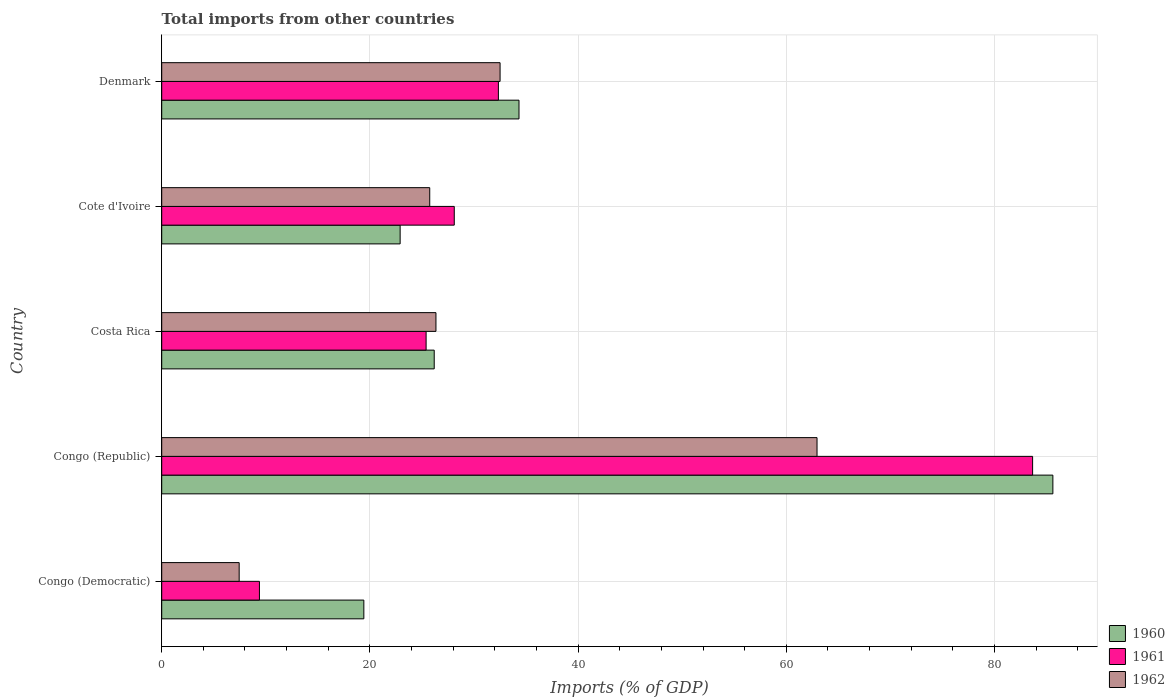How many different coloured bars are there?
Your response must be concise. 3. Are the number of bars per tick equal to the number of legend labels?
Ensure brevity in your answer.  Yes. Are the number of bars on each tick of the Y-axis equal?
Offer a terse response. Yes. How many bars are there on the 1st tick from the top?
Your answer should be very brief. 3. What is the total imports in 1961 in Costa Rica?
Your answer should be very brief. 25.4. Across all countries, what is the maximum total imports in 1961?
Provide a succinct answer. 83.66. Across all countries, what is the minimum total imports in 1961?
Your answer should be compact. 9.39. In which country was the total imports in 1960 maximum?
Give a very brief answer. Congo (Republic). In which country was the total imports in 1961 minimum?
Your answer should be compact. Congo (Democratic). What is the total total imports in 1962 in the graph?
Ensure brevity in your answer.  154.99. What is the difference between the total imports in 1960 in Congo (Republic) and that in Cote d'Ivoire?
Offer a terse response. 62.7. What is the difference between the total imports in 1960 in Denmark and the total imports in 1962 in Costa Rica?
Keep it short and to the point. 7.98. What is the average total imports in 1962 per country?
Give a very brief answer. 31. What is the difference between the total imports in 1960 and total imports in 1961 in Denmark?
Offer a very short reply. 1.98. In how many countries, is the total imports in 1962 greater than 68 %?
Your response must be concise. 0. What is the ratio of the total imports in 1961 in Costa Rica to that in Cote d'Ivoire?
Offer a very short reply. 0.9. Is the total imports in 1960 in Congo (Democratic) less than that in Congo (Republic)?
Keep it short and to the point. Yes. What is the difference between the highest and the second highest total imports in 1962?
Make the answer very short. 30.45. What is the difference between the highest and the lowest total imports in 1961?
Your answer should be very brief. 74.27. Is the sum of the total imports in 1961 in Congo (Democratic) and Denmark greater than the maximum total imports in 1962 across all countries?
Your answer should be compact. No. Is it the case that in every country, the sum of the total imports in 1960 and total imports in 1961 is greater than the total imports in 1962?
Keep it short and to the point. Yes. Are all the bars in the graph horizontal?
Offer a terse response. Yes. How many countries are there in the graph?
Make the answer very short. 5. What is the difference between two consecutive major ticks on the X-axis?
Ensure brevity in your answer.  20. Are the values on the major ticks of X-axis written in scientific E-notation?
Your answer should be compact. No. How are the legend labels stacked?
Keep it short and to the point. Vertical. What is the title of the graph?
Your response must be concise. Total imports from other countries. What is the label or title of the X-axis?
Give a very brief answer. Imports (% of GDP). What is the Imports (% of GDP) of 1960 in Congo (Democratic)?
Provide a short and direct response. 19.42. What is the Imports (% of GDP) of 1961 in Congo (Democratic)?
Keep it short and to the point. 9.39. What is the Imports (% of GDP) in 1962 in Congo (Democratic)?
Your answer should be compact. 7.44. What is the Imports (% of GDP) of 1960 in Congo (Republic)?
Ensure brevity in your answer.  85.61. What is the Imports (% of GDP) in 1961 in Congo (Republic)?
Your answer should be very brief. 83.66. What is the Imports (% of GDP) in 1962 in Congo (Republic)?
Give a very brief answer. 62.95. What is the Imports (% of GDP) of 1960 in Costa Rica?
Give a very brief answer. 26.18. What is the Imports (% of GDP) of 1961 in Costa Rica?
Provide a succinct answer. 25.4. What is the Imports (% of GDP) in 1962 in Costa Rica?
Your answer should be compact. 26.34. What is the Imports (% of GDP) of 1960 in Cote d'Ivoire?
Ensure brevity in your answer.  22.9. What is the Imports (% of GDP) of 1961 in Cote d'Ivoire?
Offer a terse response. 28.1. What is the Imports (% of GDP) in 1962 in Cote d'Ivoire?
Keep it short and to the point. 25.75. What is the Imports (% of GDP) of 1960 in Denmark?
Ensure brevity in your answer.  34.32. What is the Imports (% of GDP) in 1961 in Denmark?
Offer a terse response. 32.34. What is the Imports (% of GDP) in 1962 in Denmark?
Ensure brevity in your answer.  32.5. Across all countries, what is the maximum Imports (% of GDP) of 1960?
Give a very brief answer. 85.61. Across all countries, what is the maximum Imports (% of GDP) in 1961?
Give a very brief answer. 83.66. Across all countries, what is the maximum Imports (% of GDP) of 1962?
Your answer should be compact. 62.95. Across all countries, what is the minimum Imports (% of GDP) of 1960?
Your answer should be very brief. 19.42. Across all countries, what is the minimum Imports (% of GDP) in 1961?
Provide a short and direct response. 9.39. Across all countries, what is the minimum Imports (% of GDP) of 1962?
Offer a terse response. 7.44. What is the total Imports (% of GDP) of 1960 in the graph?
Ensure brevity in your answer.  188.43. What is the total Imports (% of GDP) of 1961 in the graph?
Provide a short and direct response. 178.89. What is the total Imports (% of GDP) of 1962 in the graph?
Your answer should be compact. 154.99. What is the difference between the Imports (% of GDP) of 1960 in Congo (Democratic) and that in Congo (Republic)?
Keep it short and to the point. -66.19. What is the difference between the Imports (% of GDP) of 1961 in Congo (Democratic) and that in Congo (Republic)?
Give a very brief answer. -74.27. What is the difference between the Imports (% of GDP) in 1962 in Congo (Democratic) and that in Congo (Republic)?
Offer a very short reply. -55.51. What is the difference between the Imports (% of GDP) of 1960 in Congo (Democratic) and that in Costa Rica?
Offer a very short reply. -6.76. What is the difference between the Imports (% of GDP) in 1961 in Congo (Democratic) and that in Costa Rica?
Your answer should be compact. -16.01. What is the difference between the Imports (% of GDP) of 1962 in Congo (Democratic) and that in Costa Rica?
Provide a succinct answer. -18.9. What is the difference between the Imports (% of GDP) in 1960 in Congo (Democratic) and that in Cote d'Ivoire?
Give a very brief answer. -3.49. What is the difference between the Imports (% of GDP) of 1961 in Congo (Democratic) and that in Cote d'Ivoire?
Provide a succinct answer. -18.72. What is the difference between the Imports (% of GDP) in 1962 in Congo (Democratic) and that in Cote d'Ivoire?
Make the answer very short. -18.31. What is the difference between the Imports (% of GDP) in 1960 in Congo (Democratic) and that in Denmark?
Your response must be concise. -14.91. What is the difference between the Imports (% of GDP) of 1961 in Congo (Democratic) and that in Denmark?
Your answer should be very brief. -22.96. What is the difference between the Imports (% of GDP) of 1962 in Congo (Democratic) and that in Denmark?
Offer a very short reply. -25.06. What is the difference between the Imports (% of GDP) of 1960 in Congo (Republic) and that in Costa Rica?
Provide a succinct answer. 59.43. What is the difference between the Imports (% of GDP) in 1961 in Congo (Republic) and that in Costa Rica?
Offer a terse response. 58.26. What is the difference between the Imports (% of GDP) of 1962 in Congo (Republic) and that in Costa Rica?
Keep it short and to the point. 36.61. What is the difference between the Imports (% of GDP) of 1960 in Congo (Republic) and that in Cote d'Ivoire?
Give a very brief answer. 62.7. What is the difference between the Imports (% of GDP) of 1961 in Congo (Republic) and that in Cote d'Ivoire?
Your answer should be compact. 55.56. What is the difference between the Imports (% of GDP) in 1962 in Congo (Republic) and that in Cote d'Ivoire?
Offer a very short reply. 37.2. What is the difference between the Imports (% of GDP) in 1960 in Congo (Republic) and that in Denmark?
Make the answer very short. 51.29. What is the difference between the Imports (% of GDP) in 1961 in Congo (Republic) and that in Denmark?
Keep it short and to the point. 51.32. What is the difference between the Imports (% of GDP) in 1962 in Congo (Republic) and that in Denmark?
Provide a succinct answer. 30.45. What is the difference between the Imports (% of GDP) of 1960 in Costa Rica and that in Cote d'Ivoire?
Provide a succinct answer. 3.27. What is the difference between the Imports (% of GDP) of 1961 in Costa Rica and that in Cote d'Ivoire?
Make the answer very short. -2.71. What is the difference between the Imports (% of GDP) of 1962 in Costa Rica and that in Cote d'Ivoire?
Your answer should be compact. 0.6. What is the difference between the Imports (% of GDP) in 1960 in Costa Rica and that in Denmark?
Offer a terse response. -8.14. What is the difference between the Imports (% of GDP) in 1961 in Costa Rica and that in Denmark?
Your response must be concise. -6.94. What is the difference between the Imports (% of GDP) in 1962 in Costa Rica and that in Denmark?
Your answer should be compact. -6.16. What is the difference between the Imports (% of GDP) in 1960 in Cote d'Ivoire and that in Denmark?
Ensure brevity in your answer.  -11.42. What is the difference between the Imports (% of GDP) in 1961 in Cote d'Ivoire and that in Denmark?
Provide a short and direct response. -4.24. What is the difference between the Imports (% of GDP) in 1962 in Cote d'Ivoire and that in Denmark?
Your answer should be very brief. -6.76. What is the difference between the Imports (% of GDP) in 1960 in Congo (Democratic) and the Imports (% of GDP) in 1961 in Congo (Republic)?
Make the answer very short. -64.24. What is the difference between the Imports (% of GDP) of 1960 in Congo (Democratic) and the Imports (% of GDP) of 1962 in Congo (Republic)?
Keep it short and to the point. -43.54. What is the difference between the Imports (% of GDP) of 1961 in Congo (Democratic) and the Imports (% of GDP) of 1962 in Congo (Republic)?
Ensure brevity in your answer.  -53.56. What is the difference between the Imports (% of GDP) in 1960 in Congo (Democratic) and the Imports (% of GDP) in 1961 in Costa Rica?
Keep it short and to the point. -5.98. What is the difference between the Imports (% of GDP) of 1960 in Congo (Democratic) and the Imports (% of GDP) of 1962 in Costa Rica?
Make the answer very short. -6.93. What is the difference between the Imports (% of GDP) in 1961 in Congo (Democratic) and the Imports (% of GDP) in 1962 in Costa Rica?
Provide a succinct answer. -16.96. What is the difference between the Imports (% of GDP) of 1960 in Congo (Democratic) and the Imports (% of GDP) of 1961 in Cote d'Ivoire?
Keep it short and to the point. -8.69. What is the difference between the Imports (% of GDP) in 1960 in Congo (Democratic) and the Imports (% of GDP) in 1962 in Cote d'Ivoire?
Ensure brevity in your answer.  -6.33. What is the difference between the Imports (% of GDP) of 1961 in Congo (Democratic) and the Imports (% of GDP) of 1962 in Cote d'Ivoire?
Offer a very short reply. -16.36. What is the difference between the Imports (% of GDP) of 1960 in Congo (Democratic) and the Imports (% of GDP) of 1961 in Denmark?
Your response must be concise. -12.93. What is the difference between the Imports (% of GDP) in 1960 in Congo (Democratic) and the Imports (% of GDP) in 1962 in Denmark?
Your answer should be compact. -13.09. What is the difference between the Imports (% of GDP) in 1961 in Congo (Democratic) and the Imports (% of GDP) in 1962 in Denmark?
Make the answer very short. -23.12. What is the difference between the Imports (% of GDP) in 1960 in Congo (Republic) and the Imports (% of GDP) in 1961 in Costa Rica?
Give a very brief answer. 60.21. What is the difference between the Imports (% of GDP) of 1960 in Congo (Republic) and the Imports (% of GDP) of 1962 in Costa Rica?
Your answer should be compact. 59.26. What is the difference between the Imports (% of GDP) of 1961 in Congo (Republic) and the Imports (% of GDP) of 1962 in Costa Rica?
Offer a terse response. 57.32. What is the difference between the Imports (% of GDP) in 1960 in Congo (Republic) and the Imports (% of GDP) in 1961 in Cote d'Ivoire?
Provide a short and direct response. 57.5. What is the difference between the Imports (% of GDP) of 1960 in Congo (Republic) and the Imports (% of GDP) of 1962 in Cote d'Ivoire?
Give a very brief answer. 59.86. What is the difference between the Imports (% of GDP) of 1961 in Congo (Republic) and the Imports (% of GDP) of 1962 in Cote d'Ivoire?
Your answer should be very brief. 57.91. What is the difference between the Imports (% of GDP) in 1960 in Congo (Republic) and the Imports (% of GDP) in 1961 in Denmark?
Ensure brevity in your answer.  53.26. What is the difference between the Imports (% of GDP) of 1960 in Congo (Republic) and the Imports (% of GDP) of 1962 in Denmark?
Your answer should be very brief. 53.1. What is the difference between the Imports (% of GDP) in 1961 in Congo (Republic) and the Imports (% of GDP) in 1962 in Denmark?
Your response must be concise. 51.16. What is the difference between the Imports (% of GDP) of 1960 in Costa Rica and the Imports (% of GDP) of 1961 in Cote d'Ivoire?
Ensure brevity in your answer.  -1.93. What is the difference between the Imports (% of GDP) of 1960 in Costa Rica and the Imports (% of GDP) of 1962 in Cote d'Ivoire?
Give a very brief answer. 0.43. What is the difference between the Imports (% of GDP) in 1961 in Costa Rica and the Imports (% of GDP) in 1962 in Cote d'Ivoire?
Give a very brief answer. -0.35. What is the difference between the Imports (% of GDP) of 1960 in Costa Rica and the Imports (% of GDP) of 1961 in Denmark?
Offer a terse response. -6.17. What is the difference between the Imports (% of GDP) in 1960 in Costa Rica and the Imports (% of GDP) in 1962 in Denmark?
Offer a terse response. -6.33. What is the difference between the Imports (% of GDP) of 1961 in Costa Rica and the Imports (% of GDP) of 1962 in Denmark?
Your answer should be very brief. -7.11. What is the difference between the Imports (% of GDP) of 1960 in Cote d'Ivoire and the Imports (% of GDP) of 1961 in Denmark?
Your answer should be compact. -9.44. What is the difference between the Imports (% of GDP) of 1960 in Cote d'Ivoire and the Imports (% of GDP) of 1962 in Denmark?
Ensure brevity in your answer.  -9.6. What is the difference between the Imports (% of GDP) of 1961 in Cote d'Ivoire and the Imports (% of GDP) of 1962 in Denmark?
Provide a succinct answer. -4.4. What is the average Imports (% of GDP) in 1960 per country?
Provide a short and direct response. 37.69. What is the average Imports (% of GDP) of 1961 per country?
Your answer should be compact. 35.78. What is the average Imports (% of GDP) of 1962 per country?
Make the answer very short. 31. What is the difference between the Imports (% of GDP) in 1960 and Imports (% of GDP) in 1961 in Congo (Democratic)?
Offer a very short reply. 10.03. What is the difference between the Imports (% of GDP) of 1960 and Imports (% of GDP) of 1962 in Congo (Democratic)?
Your response must be concise. 11.98. What is the difference between the Imports (% of GDP) in 1961 and Imports (% of GDP) in 1962 in Congo (Democratic)?
Offer a very short reply. 1.95. What is the difference between the Imports (% of GDP) in 1960 and Imports (% of GDP) in 1961 in Congo (Republic)?
Your answer should be compact. 1.95. What is the difference between the Imports (% of GDP) of 1960 and Imports (% of GDP) of 1962 in Congo (Republic)?
Make the answer very short. 22.66. What is the difference between the Imports (% of GDP) in 1961 and Imports (% of GDP) in 1962 in Congo (Republic)?
Ensure brevity in your answer.  20.71. What is the difference between the Imports (% of GDP) in 1960 and Imports (% of GDP) in 1961 in Costa Rica?
Keep it short and to the point. 0.78. What is the difference between the Imports (% of GDP) in 1960 and Imports (% of GDP) in 1962 in Costa Rica?
Your answer should be very brief. -0.17. What is the difference between the Imports (% of GDP) of 1961 and Imports (% of GDP) of 1962 in Costa Rica?
Offer a very short reply. -0.95. What is the difference between the Imports (% of GDP) of 1960 and Imports (% of GDP) of 1961 in Cote d'Ivoire?
Your response must be concise. -5.2. What is the difference between the Imports (% of GDP) of 1960 and Imports (% of GDP) of 1962 in Cote d'Ivoire?
Offer a terse response. -2.84. What is the difference between the Imports (% of GDP) in 1961 and Imports (% of GDP) in 1962 in Cote d'Ivoire?
Your response must be concise. 2.36. What is the difference between the Imports (% of GDP) in 1960 and Imports (% of GDP) in 1961 in Denmark?
Your answer should be compact. 1.98. What is the difference between the Imports (% of GDP) in 1960 and Imports (% of GDP) in 1962 in Denmark?
Keep it short and to the point. 1.82. What is the difference between the Imports (% of GDP) of 1961 and Imports (% of GDP) of 1962 in Denmark?
Give a very brief answer. -0.16. What is the ratio of the Imports (% of GDP) of 1960 in Congo (Democratic) to that in Congo (Republic)?
Your answer should be compact. 0.23. What is the ratio of the Imports (% of GDP) of 1961 in Congo (Democratic) to that in Congo (Republic)?
Make the answer very short. 0.11. What is the ratio of the Imports (% of GDP) in 1962 in Congo (Democratic) to that in Congo (Republic)?
Your response must be concise. 0.12. What is the ratio of the Imports (% of GDP) in 1960 in Congo (Democratic) to that in Costa Rica?
Provide a short and direct response. 0.74. What is the ratio of the Imports (% of GDP) of 1961 in Congo (Democratic) to that in Costa Rica?
Ensure brevity in your answer.  0.37. What is the ratio of the Imports (% of GDP) of 1962 in Congo (Democratic) to that in Costa Rica?
Make the answer very short. 0.28. What is the ratio of the Imports (% of GDP) in 1960 in Congo (Democratic) to that in Cote d'Ivoire?
Give a very brief answer. 0.85. What is the ratio of the Imports (% of GDP) in 1961 in Congo (Democratic) to that in Cote d'Ivoire?
Provide a succinct answer. 0.33. What is the ratio of the Imports (% of GDP) in 1962 in Congo (Democratic) to that in Cote d'Ivoire?
Give a very brief answer. 0.29. What is the ratio of the Imports (% of GDP) in 1960 in Congo (Democratic) to that in Denmark?
Your answer should be compact. 0.57. What is the ratio of the Imports (% of GDP) in 1961 in Congo (Democratic) to that in Denmark?
Your response must be concise. 0.29. What is the ratio of the Imports (% of GDP) of 1962 in Congo (Democratic) to that in Denmark?
Provide a succinct answer. 0.23. What is the ratio of the Imports (% of GDP) of 1960 in Congo (Republic) to that in Costa Rica?
Your answer should be compact. 3.27. What is the ratio of the Imports (% of GDP) in 1961 in Congo (Republic) to that in Costa Rica?
Keep it short and to the point. 3.29. What is the ratio of the Imports (% of GDP) of 1962 in Congo (Republic) to that in Costa Rica?
Keep it short and to the point. 2.39. What is the ratio of the Imports (% of GDP) in 1960 in Congo (Republic) to that in Cote d'Ivoire?
Ensure brevity in your answer.  3.74. What is the ratio of the Imports (% of GDP) in 1961 in Congo (Republic) to that in Cote d'Ivoire?
Provide a short and direct response. 2.98. What is the ratio of the Imports (% of GDP) of 1962 in Congo (Republic) to that in Cote d'Ivoire?
Give a very brief answer. 2.44. What is the ratio of the Imports (% of GDP) of 1960 in Congo (Republic) to that in Denmark?
Your response must be concise. 2.49. What is the ratio of the Imports (% of GDP) of 1961 in Congo (Republic) to that in Denmark?
Offer a terse response. 2.59. What is the ratio of the Imports (% of GDP) of 1962 in Congo (Republic) to that in Denmark?
Make the answer very short. 1.94. What is the ratio of the Imports (% of GDP) in 1961 in Costa Rica to that in Cote d'Ivoire?
Provide a succinct answer. 0.9. What is the ratio of the Imports (% of GDP) of 1962 in Costa Rica to that in Cote d'Ivoire?
Give a very brief answer. 1.02. What is the ratio of the Imports (% of GDP) of 1960 in Costa Rica to that in Denmark?
Your answer should be compact. 0.76. What is the ratio of the Imports (% of GDP) in 1961 in Costa Rica to that in Denmark?
Your response must be concise. 0.79. What is the ratio of the Imports (% of GDP) in 1962 in Costa Rica to that in Denmark?
Your response must be concise. 0.81. What is the ratio of the Imports (% of GDP) of 1960 in Cote d'Ivoire to that in Denmark?
Provide a short and direct response. 0.67. What is the ratio of the Imports (% of GDP) in 1961 in Cote d'Ivoire to that in Denmark?
Your answer should be compact. 0.87. What is the ratio of the Imports (% of GDP) of 1962 in Cote d'Ivoire to that in Denmark?
Your answer should be very brief. 0.79. What is the difference between the highest and the second highest Imports (% of GDP) of 1960?
Make the answer very short. 51.29. What is the difference between the highest and the second highest Imports (% of GDP) of 1961?
Your answer should be very brief. 51.32. What is the difference between the highest and the second highest Imports (% of GDP) in 1962?
Make the answer very short. 30.45. What is the difference between the highest and the lowest Imports (% of GDP) of 1960?
Your answer should be very brief. 66.19. What is the difference between the highest and the lowest Imports (% of GDP) in 1961?
Give a very brief answer. 74.27. What is the difference between the highest and the lowest Imports (% of GDP) in 1962?
Your answer should be compact. 55.51. 